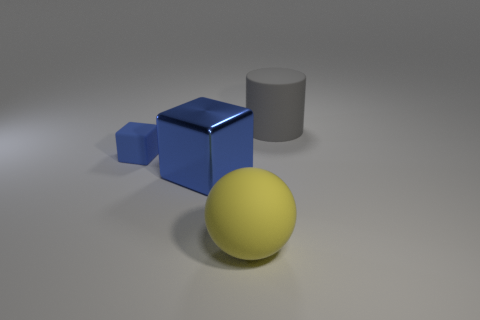Add 4 tiny green cubes. How many objects exist? 8 Subtract all cylinders. How many objects are left? 3 Subtract all red balls. Subtract all tiny blue things. How many objects are left? 3 Add 4 matte balls. How many matte balls are left? 5 Add 3 matte cylinders. How many matte cylinders exist? 4 Subtract 0 green blocks. How many objects are left? 4 